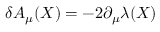Convert formula to latex. <formula><loc_0><loc_0><loc_500><loc_500>\delta A _ { \mu } ( X ) = - 2 \partial _ { \mu } \lambda ( X )</formula> 